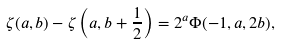<formula> <loc_0><loc_0><loc_500><loc_500>\zeta ( a , b ) - \zeta \left ( a , b + \frac { 1 } { 2 } \right ) = 2 ^ { a } \Phi ( - 1 , a , 2 b ) ,</formula> 